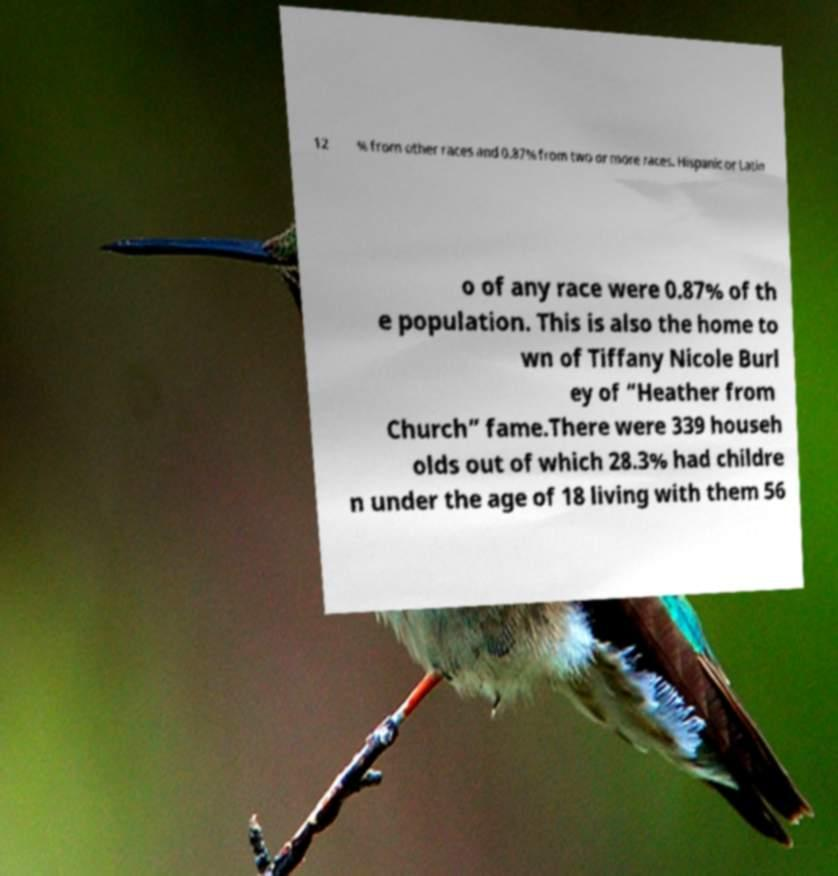Can you accurately transcribe the text from the provided image for me? 12 % from other races and 0.87% from two or more races. Hispanic or Latin o of any race were 0.87% of th e population. This is also the home to wn of Tiffany Nicole Burl ey of “Heather from Church” fame.There were 339 househ olds out of which 28.3% had childre n under the age of 18 living with them 56 